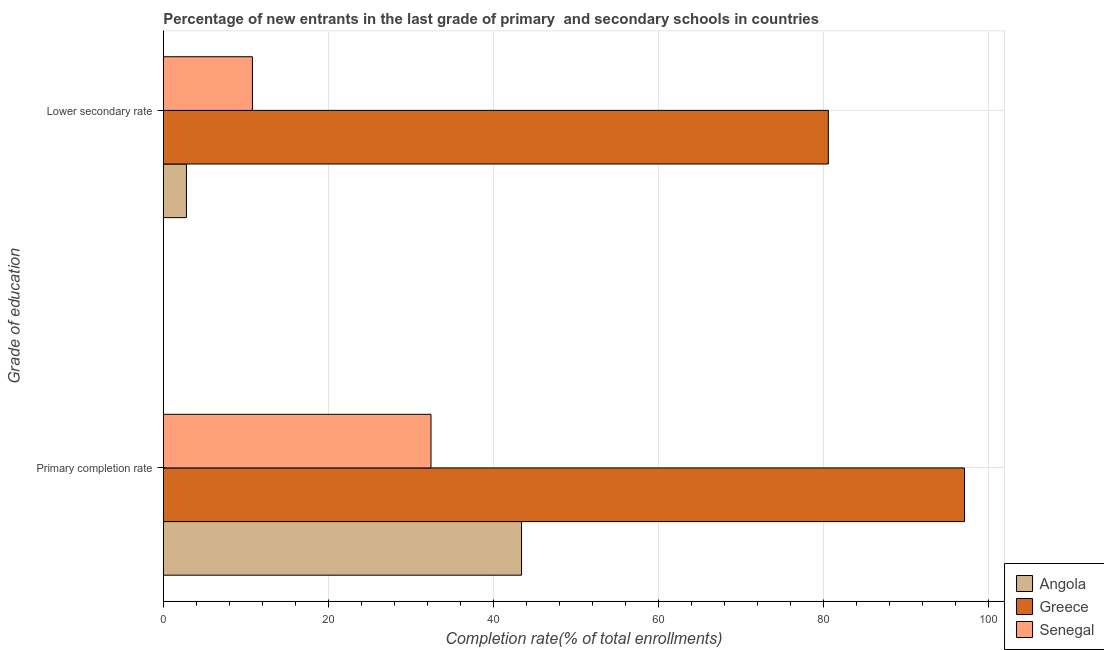How many different coloured bars are there?
Provide a short and direct response. 3. How many groups of bars are there?
Offer a terse response. 2. Are the number of bars per tick equal to the number of legend labels?
Provide a succinct answer. Yes. How many bars are there on the 1st tick from the top?
Offer a very short reply. 3. What is the label of the 2nd group of bars from the top?
Keep it short and to the point. Primary completion rate. What is the completion rate in secondary schools in Greece?
Your answer should be very brief. 80.62. Across all countries, what is the maximum completion rate in secondary schools?
Make the answer very short. 80.62. Across all countries, what is the minimum completion rate in primary schools?
Your answer should be compact. 32.45. In which country was the completion rate in primary schools minimum?
Offer a terse response. Senegal. What is the total completion rate in secondary schools in the graph?
Give a very brief answer. 94.23. What is the difference between the completion rate in primary schools in Angola and that in Greece?
Provide a succinct answer. -53.69. What is the difference between the completion rate in primary schools in Greece and the completion rate in secondary schools in Senegal?
Make the answer very short. 86.31. What is the average completion rate in secondary schools per country?
Ensure brevity in your answer.  31.41. What is the difference between the completion rate in secondary schools and completion rate in primary schools in Senegal?
Offer a very short reply. -21.65. What is the ratio of the completion rate in secondary schools in Angola to that in Greece?
Offer a very short reply. 0.03. Is the completion rate in primary schools in Angola less than that in Senegal?
Make the answer very short. No. What does the 2nd bar from the top in Primary completion rate represents?
Your answer should be very brief. Greece. What does the 3rd bar from the bottom in Primary completion rate represents?
Offer a terse response. Senegal. How many bars are there?
Ensure brevity in your answer.  6. How many countries are there in the graph?
Ensure brevity in your answer.  3. What is the difference between two consecutive major ticks on the X-axis?
Give a very brief answer. 20. Are the values on the major ticks of X-axis written in scientific E-notation?
Your response must be concise. No. Does the graph contain grids?
Keep it short and to the point. Yes. Where does the legend appear in the graph?
Ensure brevity in your answer.  Bottom right. How many legend labels are there?
Provide a short and direct response. 3. How are the legend labels stacked?
Provide a succinct answer. Vertical. What is the title of the graph?
Make the answer very short. Percentage of new entrants in the last grade of primary  and secondary schools in countries. What is the label or title of the X-axis?
Provide a succinct answer. Completion rate(% of total enrollments). What is the label or title of the Y-axis?
Keep it short and to the point. Grade of education. What is the Completion rate(% of total enrollments) of Angola in Primary completion rate?
Your response must be concise. 43.43. What is the Completion rate(% of total enrollments) of Greece in Primary completion rate?
Offer a very short reply. 97.12. What is the Completion rate(% of total enrollments) of Senegal in Primary completion rate?
Offer a very short reply. 32.45. What is the Completion rate(% of total enrollments) in Angola in Lower secondary rate?
Offer a very short reply. 2.81. What is the Completion rate(% of total enrollments) of Greece in Lower secondary rate?
Ensure brevity in your answer.  80.62. What is the Completion rate(% of total enrollments) in Senegal in Lower secondary rate?
Your answer should be very brief. 10.81. Across all Grade of education, what is the maximum Completion rate(% of total enrollments) in Angola?
Give a very brief answer. 43.43. Across all Grade of education, what is the maximum Completion rate(% of total enrollments) of Greece?
Make the answer very short. 97.12. Across all Grade of education, what is the maximum Completion rate(% of total enrollments) in Senegal?
Keep it short and to the point. 32.45. Across all Grade of education, what is the minimum Completion rate(% of total enrollments) of Angola?
Your response must be concise. 2.81. Across all Grade of education, what is the minimum Completion rate(% of total enrollments) of Greece?
Provide a succinct answer. 80.62. Across all Grade of education, what is the minimum Completion rate(% of total enrollments) in Senegal?
Offer a terse response. 10.81. What is the total Completion rate(% of total enrollments) in Angola in the graph?
Offer a terse response. 46.24. What is the total Completion rate(% of total enrollments) in Greece in the graph?
Provide a short and direct response. 177.74. What is the total Completion rate(% of total enrollments) of Senegal in the graph?
Give a very brief answer. 43.26. What is the difference between the Completion rate(% of total enrollments) in Angola in Primary completion rate and that in Lower secondary rate?
Make the answer very short. 40.62. What is the difference between the Completion rate(% of total enrollments) in Greece in Primary completion rate and that in Lower secondary rate?
Keep it short and to the point. 16.5. What is the difference between the Completion rate(% of total enrollments) of Senegal in Primary completion rate and that in Lower secondary rate?
Provide a short and direct response. 21.65. What is the difference between the Completion rate(% of total enrollments) of Angola in Primary completion rate and the Completion rate(% of total enrollments) of Greece in Lower secondary rate?
Keep it short and to the point. -37.19. What is the difference between the Completion rate(% of total enrollments) of Angola in Primary completion rate and the Completion rate(% of total enrollments) of Senegal in Lower secondary rate?
Make the answer very short. 32.62. What is the difference between the Completion rate(% of total enrollments) of Greece in Primary completion rate and the Completion rate(% of total enrollments) of Senegal in Lower secondary rate?
Offer a very short reply. 86.31. What is the average Completion rate(% of total enrollments) in Angola per Grade of education?
Ensure brevity in your answer.  23.12. What is the average Completion rate(% of total enrollments) in Greece per Grade of education?
Give a very brief answer. 88.87. What is the average Completion rate(% of total enrollments) of Senegal per Grade of education?
Your answer should be very brief. 21.63. What is the difference between the Completion rate(% of total enrollments) in Angola and Completion rate(% of total enrollments) in Greece in Primary completion rate?
Provide a short and direct response. -53.69. What is the difference between the Completion rate(% of total enrollments) of Angola and Completion rate(% of total enrollments) of Senegal in Primary completion rate?
Provide a succinct answer. 10.97. What is the difference between the Completion rate(% of total enrollments) in Greece and Completion rate(% of total enrollments) in Senegal in Primary completion rate?
Provide a short and direct response. 64.66. What is the difference between the Completion rate(% of total enrollments) in Angola and Completion rate(% of total enrollments) in Greece in Lower secondary rate?
Offer a terse response. -77.81. What is the difference between the Completion rate(% of total enrollments) of Angola and Completion rate(% of total enrollments) of Senegal in Lower secondary rate?
Your answer should be compact. -8. What is the difference between the Completion rate(% of total enrollments) in Greece and Completion rate(% of total enrollments) in Senegal in Lower secondary rate?
Provide a succinct answer. 69.81. What is the ratio of the Completion rate(% of total enrollments) of Angola in Primary completion rate to that in Lower secondary rate?
Offer a terse response. 15.46. What is the ratio of the Completion rate(% of total enrollments) in Greece in Primary completion rate to that in Lower secondary rate?
Ensure brevity in your answer.  1.2. What is the ratio of the Completion rate(% of total enrollments) in Senegal in Primary completion rate to that in Lower secondary rate?
Keep it short and to the point. 3. What is the difference between the highest and the second highest Completion rate(% of total enrollments) of Angola?
Your answer should be compact. 40.62. What is the difference between the highest and the second highest Completion rate(% of total enrollments) in Greece?
Your answer should be compact. 16.5. What is the difference between the highest and the second highest Completion rate(% of total enrollments) in Senegal?
Provide a short and direct response. 21.65. What is the difference between the highest and the lowest Completion rate(% of total enrollments) of Angola?
Your answer should be very brief. 40.62. What is the difference between the highest and the lowest Completion rate(% of total enrollments) in Greece?
Your response must be concise. 16.5. What is the difference between the highest and the lowest Completion rate(% of total enrollments) in Senegal?
Your answer should be compact. 21.65. 